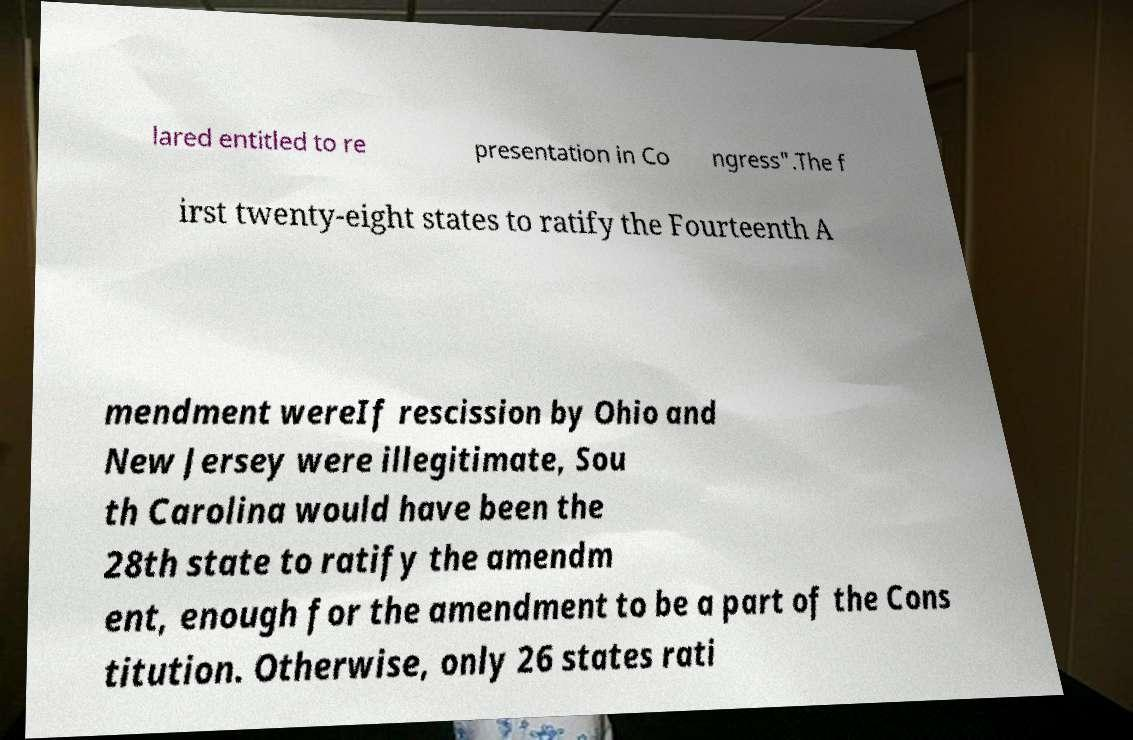Please read and relay the text visible in this image. What does it say? lared entitled to re presentation in Co ngress".The f irst twenty-eight states to ratify the Fourteenth A mendment wereIf rescission by Ohio and New Jersey were illegitimate, Sou th Carolina would have been the 28th state to ratify the amendm ent, enough for the amendment to be a part of the Cons titution. Otherwise, only 26 states rati 